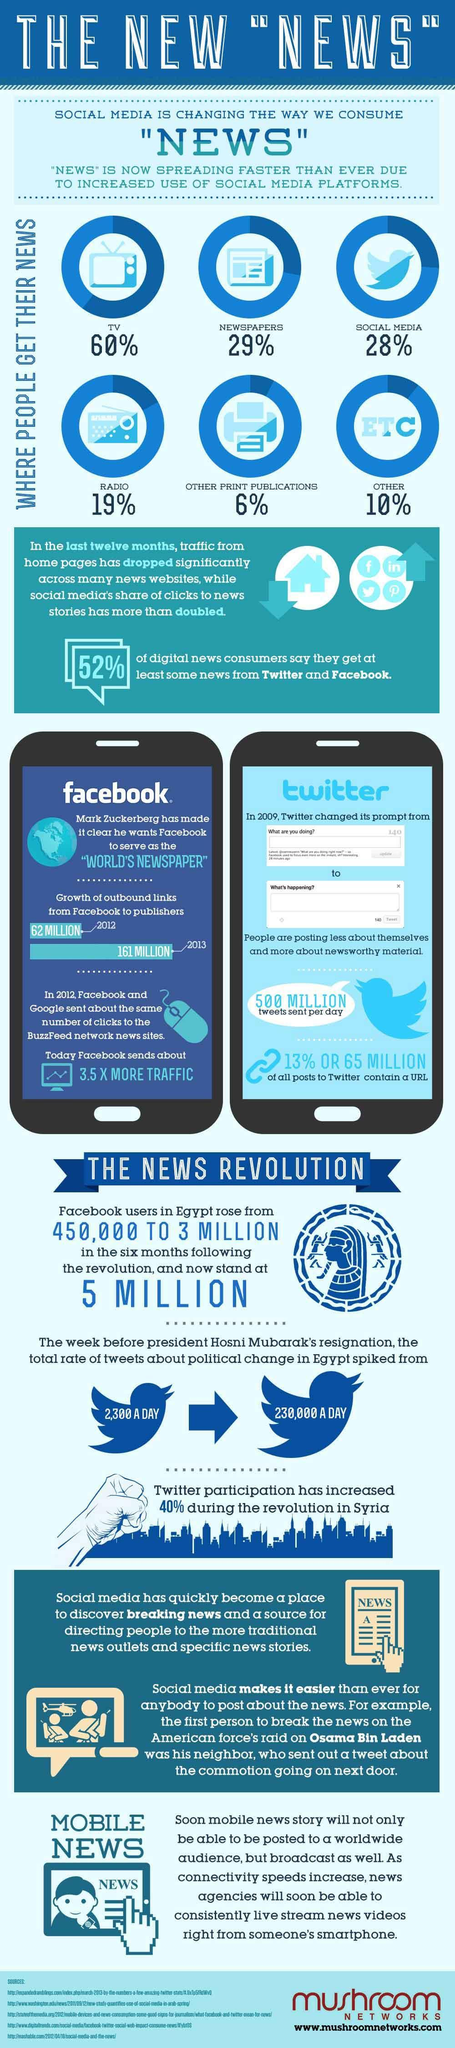Where do most people get their news?
Answer the question with a short phrase. TV What percentage of people get their news through social media? 28% What percentage of people get their news through radio? 19% What is the growth of outbound links from Facebook to publishers in 2013? 161 MILLION What is the number of Tweets sent per day in 2009? 500 MILLION 